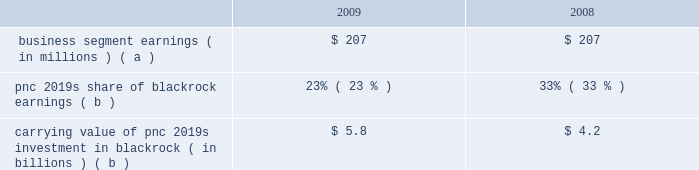Blackrock information related to our equity investment in blackrock follows: .
Carrying value of pnc 2019s investment in blackrock ( in billions ) ( b ) $ 5.8 $ 4.2 ( a ) includes pnc 2019s share of blackrock 2019s reported gaap earnings and additional income taxes on those earnings incurred by pnc .
( b ) at december 31 .
Blackrock/barclays global investors transaction on december 1 , 2009 , blackrock acquired bgi from barclays bank plc in exchange for approximately $ 6.65 billion in cash and 37566771 shares of blackrock common and participating preferred stock .
In connection with the bgi transaction , blackrock entered into amendments to stockholder agreements with pnc and its other major shareholder .
These amendments , which changed certain shareholder rights , including composition of the blackrock board of directors and share transfer restrictions , became effective upon closing of the bgi transaction .
Also in connection with the bgi transaction , blackrock entered into a stock purchase agreement with pnc in which we purchased 3556188 shares of blackrock 2019s series d preferred stock at a price of $ 140.60 per share , or $ 500 million , to partially finance the transaction .
On january 31 , 2010 , the series d preferred stock was converted to series b preferred stock .
Upon closing of the bgi transaction , the carrying value of our investment in blackrock increased significantly , reflecting our portion of the increase in blackrock 2019s equity resulting from the value of blackrock shares issued in connection with their acquisition of bgi .
Pnc recognized this increase in value as a $ 1.076 billion pretax gain in the fourth quarter of 2009 .
At december 31 , 2009 , our percentage ownership of blackrock common stock was approximately 35% ( 35 % ) .
Blackrock ltip programs and exchange agreements pnc 2019s noninterest income included pretax gains of $ 98 million in 2009 and $ 243 million in 2008 related to our blackrock ltip shares obligation .
These gains represented the mark-to-market adjustment related to our remaining blackrock ltip common shares obligation and resulted from the decrease in the market value of blackrock common shares in those periods .
As previously reported , pnc entered into an exchange agreement with blackrock on december 26 , 2008 .
The transactions that resulted from this agreement restructured pnc 2019s ownership of blackrock equity without altering , to any meaningful extent , pnc 2019s economic interest in blackrock .
Pnc continues to be subject to the limitations on its voting rights in its existing agreements with blackrock .
Also on december 26 , 2008 , blackrock entered into an exchange agreement with merrill lynch in anticipation of the consummation of the merger of bank of america corporation and merrill lynch that occurred on january 1 , 2009 .
The pnc and merrill lynch exchange agreements restructured pnc 2019s and merrill lynch 2019s respective ownership of blackrock common and preferred equity .
The exchange contemplated by these agreements was completed on february 27 , 2009 .
On that date , pnc 2019s obligation to deliver blackrock common shares was replaced with an obligation to deliver shares of blackrock 2019s new series c preferred stock .
Pnc acquired 2.9 million shares of series c preferred stock from blackrock in exchange for common shares on that same date .
Pnc accounts for these preferred shares at fair value , which offsets the impact of marking-to-market the obligation to deliver these shares to blackrock as we aligned the fair value marks on this asset and liability .
The fair value of the blackrock series c preferred stock is included on our consolidated balance sheet in other assets .
Additional information regarding the valuation of the blackrock series c preferred stock is included in note 8 fair value in the notes to consolidated financial statements included in item 8 of this report .
Pnc accounts for its remaining investment in blackrock under the equity method of accounting , with its share of blackrock 2019s earnings reduced primarily due to the exchange of blackrock common stock for blackrock series c preferred stock .
The series c preferred stock is not taken into consideration in determining pnc 2019s share of blackrock earnings under the equity method .
Pnc 2019s percentage ownership of blackrock common stock increased as a result of the substantial exchange of merrill lynch 2019s blackrock common stock for blackrock preferred stock .
As a result of the blackrock preferred stock held by merrill lynch and the new blackrock preferred stock issued to merrill lynch and pnc under the exchange agreements , pnc 2019s share of blackrock common stock is higher than its overall share of blackrock 2019s equity and earnings .
The transactions related to the exchange agreements do not affect our right to receive dividends declared by blackrock. .
What was pnc's total carrying value from 2008-09 from its investment in blackrock , in billions? 
Computations: (5.8 + 4.2)
Answer: 10.0. 